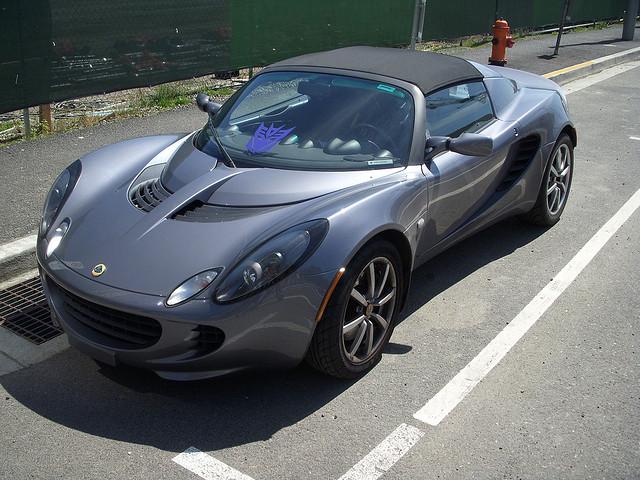Is the car parked?
Concise answer only. Yes. Is there a fire hydrant in this scene?
Write a very short answer. Yes. Is there a driver inside of the car?
Keep it brief. No. How many mirrors can you see?
Write a very short answer. 3. 